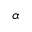<formula> <loc_0><loc_0><loc_500><loc_500>\alpha</formula> 